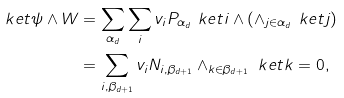<formula> <loc_0><loc_0><loc_500><loc_500>\ k e t { \psi } \wedge W & = \sum _ { \alpha _ { d } } \sum _ { i } v _ { i } P _ { \alpha _ { d } } \ k e t { i } \wedge ( \wedge _ { j \in \alpha _ { d } } \ k e t { j } ) \\ & = \sum _ { i , \beta _ { d + 1 } } v _ { i } N _ { i , \beta _ { d + 1 } } \wedge _ { k \in \beta _ { d + 1 } } \ k e t { k } = 0 ,</formula> 